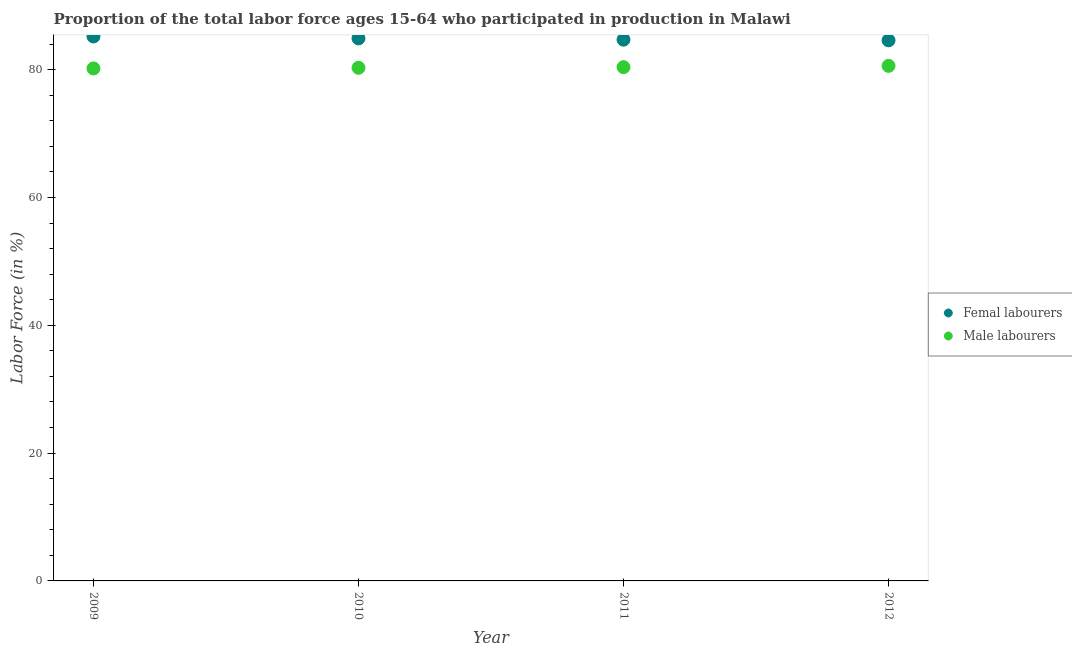Is the number of dotlines equal to the number of legend labels?
Your answer should be compact. Yes. What is the percentage of female labor force in 2011?
Ensure brevity in your answer.  84.7. Across all years, what is the maximum percentage of female labor force?
Ensure brevity in your answer.  85.2. Across all years, what is the minimum percentage of male labour force?
Your response must be concise. 80.2. In which year was the percentage of female labor force maximum?
Keep it short and to the point. 2009. What is the total percentage of female labor force in the graph?
Give a very brief answer. 339.4. What is the difference between the percentage of male labour force in 2009 and that in 2012?
Give a very brief answer. -0.4. What is the difference between the percentage of female labor force in 2010 and the percentage of male labour force in 2009?
Provide a short and direct response. 4.7. What is the average percentage of male labour force per year?
Your response must be concise. 80.37. In the year 2011, what is the difference between the percentage of female labor force and percentage of male labour force?
Your answer should be very brief. 4.3. In how many years, is the percentage of female labor force greater than 4 %?
Keep it short and to the point. 4. What is the ratio of the percentage of male labour force in 2009 to that in 2011?
Your answer should be very brief. 1. Is the percentage of male labour force in 2010 less than that in 2011?
Provide a succinct answer. Yes. What is the difference between the highest and the second highest percentage of male labour force?
Ensure brevity in your answer.  0.2. What is the difference between the highest and the lowest percentage of male labour force?
Make the answer very short. 0.4. In how many years, is the percentage of male labour force greater than the average percentage of male labour force taken over all years?
Keep it short and to the point. 2. Does the percentage of female labor force monotonically increase over the years?
Ensure brevity in your answer.  No. Is the percentage of male labour force strictly greater than the percentage of female labor force over the years?
Provide a short and direct response. No. Is the percentage of male labour force strictly less than the percentage of female labor force over the years?
Offer a very short reply. Yes. What is the difference between two consecutive major ticks on the Y-axis?
Provide a succinct answer. 20. Does the graph contain any zero values?
Provide a succinct answer. No. Where does the legend appear in the graph?
Ensure brevity in your answer.  Center right. How many legend labels are there?
Provide a succinct answer. 2. What is the title of the graph?
Ensure brevity in your answer.  Proportion of the total labor force ages 15-64 who participated in production in Malawi. What is the label or title of the Y-axis?
Offer a terse response. Labor Force (in %). What is the Labor Force (in %) of Femal labourers in 2009?
Provide a succinct answer. 85.2. What is the Labor Force (in %) of Male labourers in 2009?
Keep it short and to the point. 80.2. What is the Labor Force (in %) in Femal labourers in 2010?
Provide a short and direct response. 84.9. What is the Labor Force (in %) of Male labourers in 2010?
Your answer should be very brief. 80.3. What is the Labor Force (in %) in Femal labourers in 2011?
Provide a short and direct response. 84.7. What is the Labor Force (in %) in Male labourers in 2011?
Provide a short and direct response. 80.4. What is the Labor Force (in %) in Femal labourers in 2012?
Your answer should be compact. 84.6. What is the Labor Force (in %) in Male labourers in 2012?
Give a very brief answer. 80.6. Across all years, what is the maximum Labor Force (in %) of Femal labourers?
Ensure brevity in your answer.  85.2. Across all years, what is the maximum Labor Force (in %) of Male labourers?
Your answer should be very brief. 80.6. Across all years, what is the minimum Labor Force (in %) in Femal labourers?
Your answer should be compact. 84.6. Across all years, what is the minimum Labor Force (in %) in Male labourers?
Give a very brief answer. 80.2. What is the total Labor Force (in %) in Femal labourers in the graph?
Offer a terse response. 339.4. What is the total Labor Force (in %) in Male labourers in the graph?
Give a very brief answer. 321.5. What is the difference between the Labor Force (in %) in Femal labourers in 2009 and that in 2011?
Offer a very short reply. 0.5. What is the difference between the Labor Force (in %) in Male labourers in 2009 and that in 2011?
Your answer should be compact. -0.2. What is the difference between the Labor Force (in %) in Femal labourers in 2009 and that in 2012?
Ensure brevity in your answer.  0.6. What is the difference between the Labor Force (in %) of Femal labourers in 2010 and that in 2011?
Your answer should be compact. 0.2. What is the difference between the Labor Force (in %) in Male labourers in 2010 and that in 2012?
Offer a very short reply. -0.3. What is the difference between the Labor Force (in %) in Femal labourers in 2009 and the Labor Force (in %) in Male labourers in 2010?
Provide a short and direct response. 4.9. What is the difference between the Labor Force (in %) of Femal labourers in 2011 and the Labor Force (in %) of Male labourers in 2012?
Provide a short and direct response. 4.1. What is the average Labor Force (in %) in Femal labourers per year?
Offer a terse response. 84.85. What is the average Labor Force (in %) of Male labourers per year?
Your response must be concise. 80.38. What is the ratio of the Labor Force (in %) of Femal labourers in 2009 to that in 2010?
Provide a succinct answer. 1. What is the ratio of the Labor Force (in %) of Femal labourers in 2009 to that in 2011?
Give a very brief answer. 1.01. What is the ratio of the Labor Force (in %) in Male labourers in 2009 to that in 2011?
Offer a very short reply. 1. What is the ratio of the Labor Force (in %) in Femal labourers in 2009 to that in 2012?
Offer a very short reply. 1.01. What is the ratio of the Labor Force (in %) of Male labourers in 2009 to that in 2012?
Your response must be concise. 0.99. What is the ratio of the Labor Force (in %) of Male labourers in 2010 to that in 2011?
Your answer should be compact. 1. What is the ratio of the Labor Force (in %) in Male labourers in 2011 to that in 2012?
Provide a succinct answer. 1. What is the difference between the highest and the lowest Labor Force (in %) of Male labourers?
Your answer should be very brief. 0.4. 